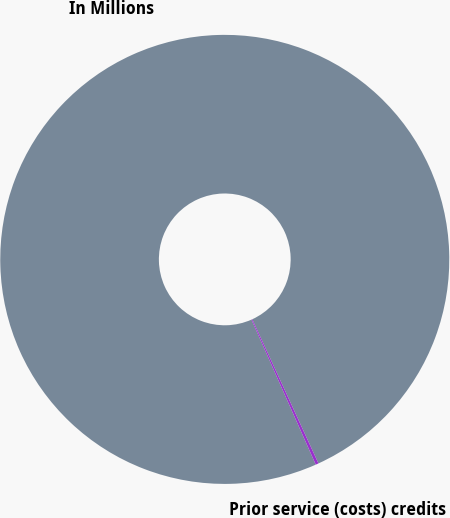Convert chart to OTSL. <chart><loc_0><loc_0><loc_500><loc_500><pie_chart><fcel>In Millions<fcel>Prior service (costs) credits<nl><fcel>99.79%<fcel>0.21%<nl></chart> 